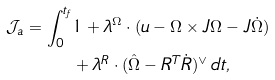<formula> <loc_0><loc_0><loc_500><loc_500>\mathcal { J } _ { a } = \int _ { 0 } ^ { t _ { f } } & 1 + \lambda ^ { \Omega } \cdot ( u - \Omega \times J \Omega - J \dot { \Omega } ) \\ & + \lambda ^ { R } \cdot ( \hat { \Omega } - R ^ { T } \dot { R } ) { ^ { \vee } } \, d t ,</formula> 